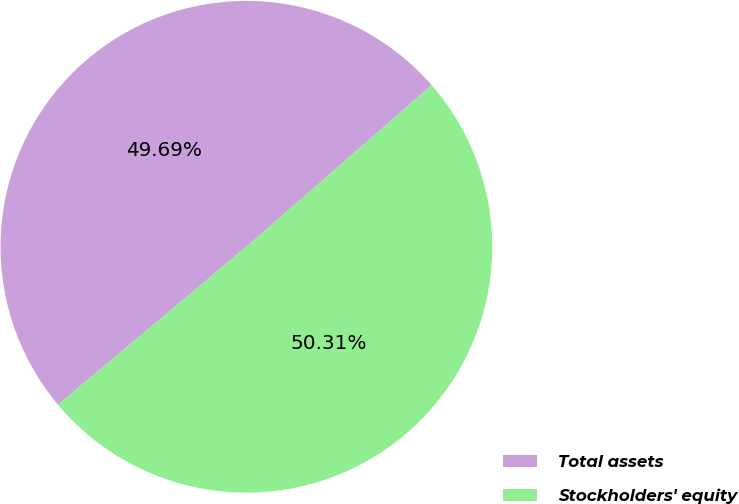<chart> <loc_0><loc_0><loc_500><loc_500><pie_chart><fcel>Total assets<fcel>Stockholders' equity<nl><fcel>49.69%<fcel>50.31%<nl></chart> 